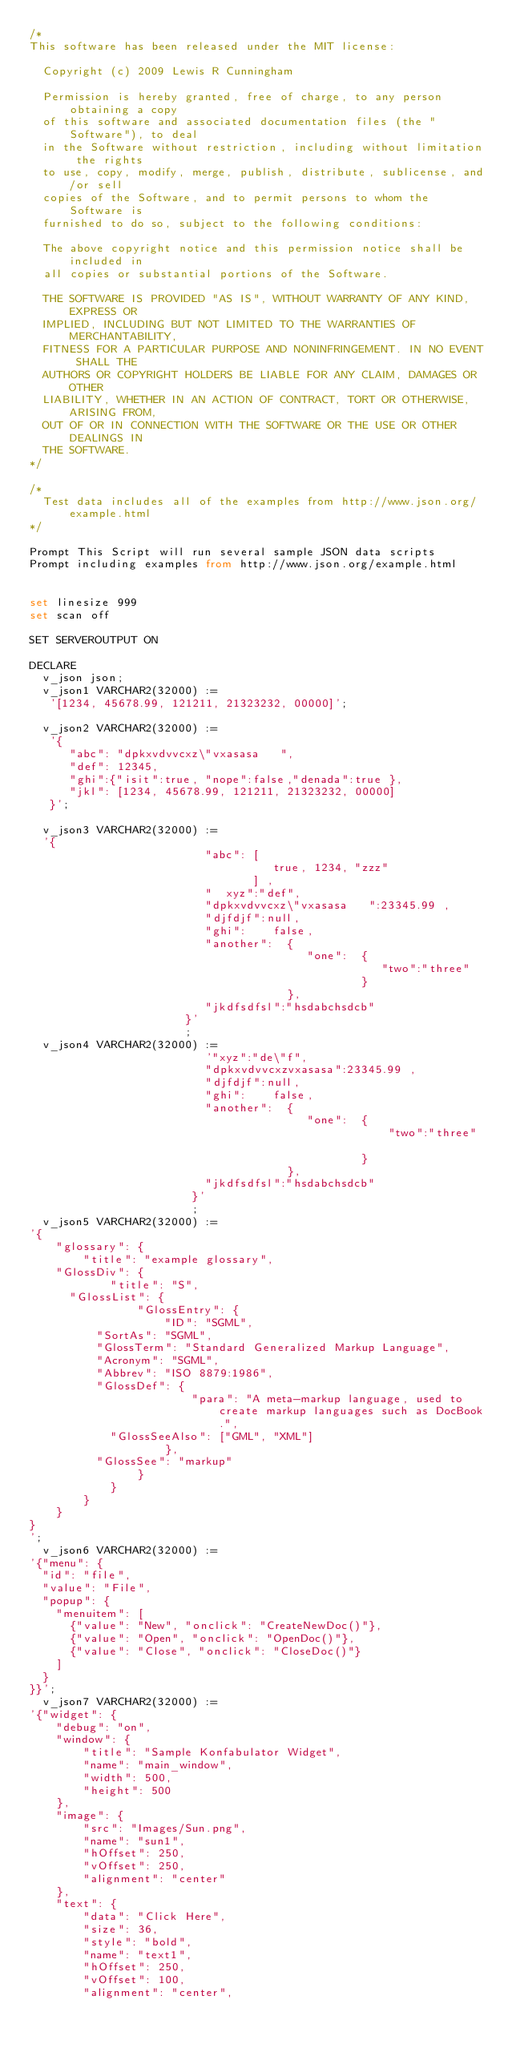<code> <loc_0><loc_0><loc_500><loc_500><_SQL_>/*
This software has been released under the MIT license:

  Copyright (c) 2009 Lewis R Cunningham

  Permission is hereby granted, free of charge, to any person obtaining a copy
  of this software and associated documentation files (the "Software"), to deal
  in the Software without restriction, including without limitation the rights
  to use, copy, modify, merge, publish, distribute, sublicense, and/or sell
  copies of the Software, and to permit persons to whom the Software is
  furnished to do so, subject to the following conditions:

  The above copyright notice and this permission notice shall be included in
  all copies or substantial portions of the Software.

  THE SOFTWARE IS PROVIDED "AS IS", WITHOUT WARRANTY OF ANY KIND, EXPRESS OR
  IMPLIED, INCLUDING BUT NOT LIMITED TO THE WARRANTIES OF MERCHANTABILITY,
  FITNESS FOR A PARTICULAR PURPOSE AND NONINFRINGEMENT. IN NO EVENT SHALL THE
  AUTHORS OR COPYRIGHT HOLDERS BE LIABLE FOR ANY CLAIM, DAMAGES OR OTHER
  LIABILITY, WHETHER IN AN ACTION OF CONTRACT, TORT OR OTHERWISE, ARISING FROM,
  OUT OF OR IN CONNECTION WITH THE SOFTWARE OR THE USE OR OTHER DEALINGS IN
  THE SOFTWARE.
*/

/*
  Test data includes all of the examples from http://www.json.org/example.html
*/

Prompt This Script will run several sample JSON data scripts
Prompt including examples from http://www.json.org/example.html


set linesize 999
set scan off

SET SERVEROUTPUT ON

DECLARE
  v_json json;
  v_json1 VARCHAR2(32000) := 
   '[1234, 45678.99, 121211, 21323232, 00000]';

  v_json2 VARCHAR2(32000) := 
   '{ 
      "abc": "dpkxvdvvcxz\"vxasasa   ",
      "def": 12345,
      "ghi":{"isit":true, "nope":false,"denada":true },
      "jkl": [1234, 45678.99, 121211, 21323232, 00000]
   }';
   
  v_json3 VARCHAR2(32000) := 
  '{
                          "abc": [
                                    true, 1234, "zzz"
                                 ] , 
                          "  xyz":"def",
                          "dpkxvdvvcxz\"vxasasa   ":23345.99 , 
                          "djfdjf":null,
                          "ghi":    false, 
                          "another":  {
                                         "one":  {
                                                    "two":"three"
                                                 }
                                      }, 
                          "jkdfsdfsl":"hsdabchsdcb"  
                       }'
                       ;
  v_json4 VARCHAR2(32000) := 
                          '"xyz":"de\"f",
                          "dpkxvdvvcxzvxasasa":23345.99 , 
                          "djfdjf":null,
                          "ghi":    false, 
                          "another":  {
                                         "one":  {
                                                     "two":"three"
                                                   
                                                 }
                                      }, 
                          "jkdfsdfsl":"hsdabchsdcb"  
                        }'
                        ;
  v_json5 VARCHAR2(32000) := 
'{
    "glossary": {
        "title": "example glossary",
		"GlossDiv": {
            "title": "S",
			"GlossList": {
                "GlossEntry": {
                    "ID": "SGML",
					"SortAs": "SGML",
					"GlossTerm": "Standard Generalized Markup Language",
					"Acronym": "SGML",
					"Abbrev": "ISO 8879:1986",
					"GlossDef": {
                        "para": "A meta-markup language, used to create markup languages such as DocBook.",
						"GlossSeeAlso": ["GML", "XML"]
                    },
					"GlossSee": "markup"
                }
            }
        }
    }
}
';  
  v_json6 VARCHAR2(32000) := 
'{"menu": {
  "id": "file",
  "value": "File",
  "popup": {
    "menuitem": [
      {"value": "New", "onclick": "CreateNewDoc()"},
      {"value": "Open", "onclick": "OpenDoc()"},
      {"value": "Close", "onclick": "CloseDoc()"}
    ]
  }
}}'; 
  v_json7 VARCHAR2(32000) := 
'{"widget": {
    "debug": "on",
    "window": {
        "title": "Sample Konfabulator Widget",
        "name": "main_window",
        "width": 500,
        "height": 500
    },
    "image": { 
        "src": "Images/Sun.png",
        "name": "sun1",
        "hOffset": 250,
        "vOffset": 250,
        "alignment": "center"
    },
    "text": {
        "data": "Click Here",
        "size": 36,
        "style": "bold",
        "name": "text1",
        "hOffset": 250,
        "vOffset": 100,
        "alignment": "center",</code> 